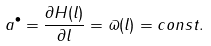<formula> <loc_0><loc_0><loc_500><loc_500>a ^ { \bullet } = \frac { \partial H ( l ) } { \partial l } = \varpi ( l ) = c o n s t .</formula> 